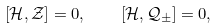Convert formula to latex. <formula><loc_0><loc_0><loc_500><loc_500>\left [ \mathcal { H } , \mathcal { Z } \right ] = 0 , \quad \left [ \mathcal { H } , \mathcal { Q } _ { \pm } \right ] = 0 ,</formula> 